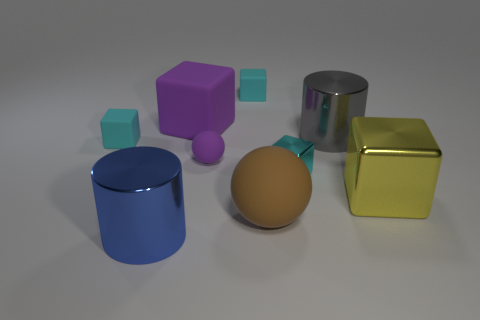Subtract all green cylinders. How many cyan cubes are left? 3 Subtract 1 blocks. How many blocks are left? 4 Subtract all yellow cubes. How many cubes are left? 4 Subtract all big yellow blocks. How many blocks are left? 4 Subtract all purple blocks. Subtract all purple cylinders. How many blocks are left? 4 Subtract all cylinders. How many objects are left? 7 Add 4 big red metal things. How many big red metal things exist? 4 Subtract 0 brown cylinders. How many objects are left? 9 Subtract all big yellow metal things. Subtract all big yellow things. How many objects are left? 7 Add 7 big brown spheres. How many big brown spheres are left? 8 